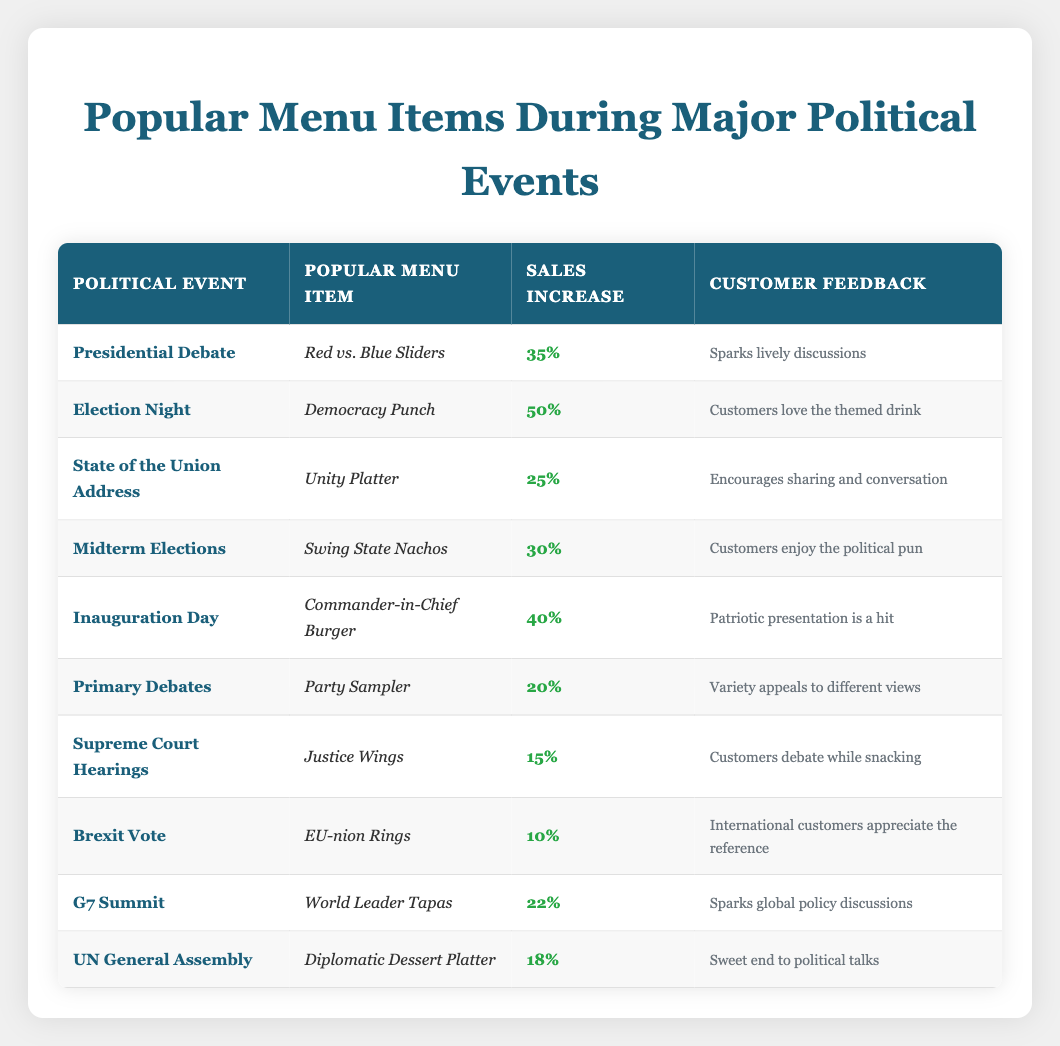What is the popular menu item during the Presidential Debate? The table lists the menu item for the Presidential Debate as "Red vs. Blue Sliders."
Answer: Red vs. Blue Sliders Which political event coincides with a 50% sales increase? The table indicates that "Election Night" corresponds with a 50% sales increase.
Answer: Election Night What is the total sales increase for the items related to the State of the Union Address and Inauguration Day? The sales increase for the State of the Union Address is 25%, and for Inauguration Day, it is 40%. Adding these gives us a total of 25% + 40% = 65%.
Answer: 65% Is the feedback for the Supreme Court Hearings positive? The feedback states "Customers debate while snacking," which implies that customers are engaged and likely enjoying the experience. This indicates positive feedback.
Answer: Yes Which menu item inspired the least increase in sales and what percentage was it? The table shows that the "EU-nion Rings" inspired the least increase in sales at 10%.
Answer: EU-nion Rings, 10% 